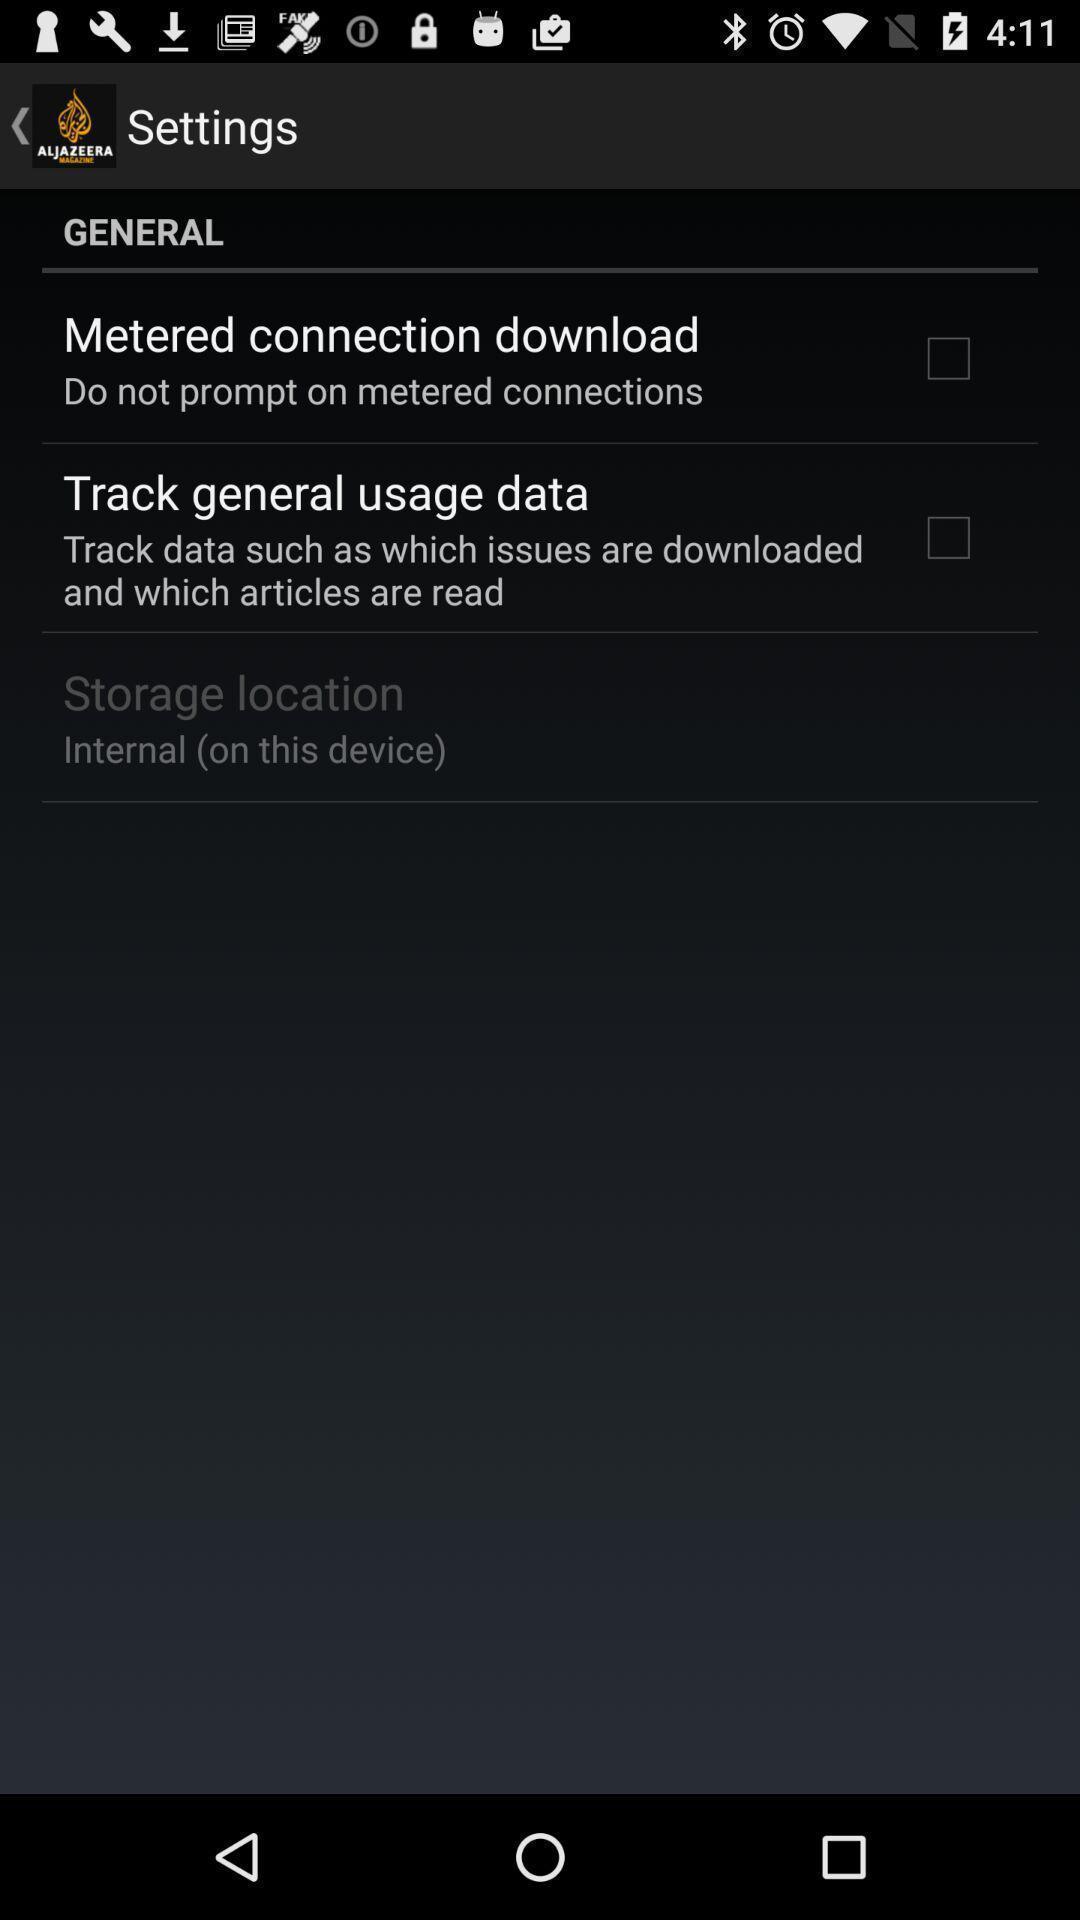Describe the key features of this screenshot. Settings page. 